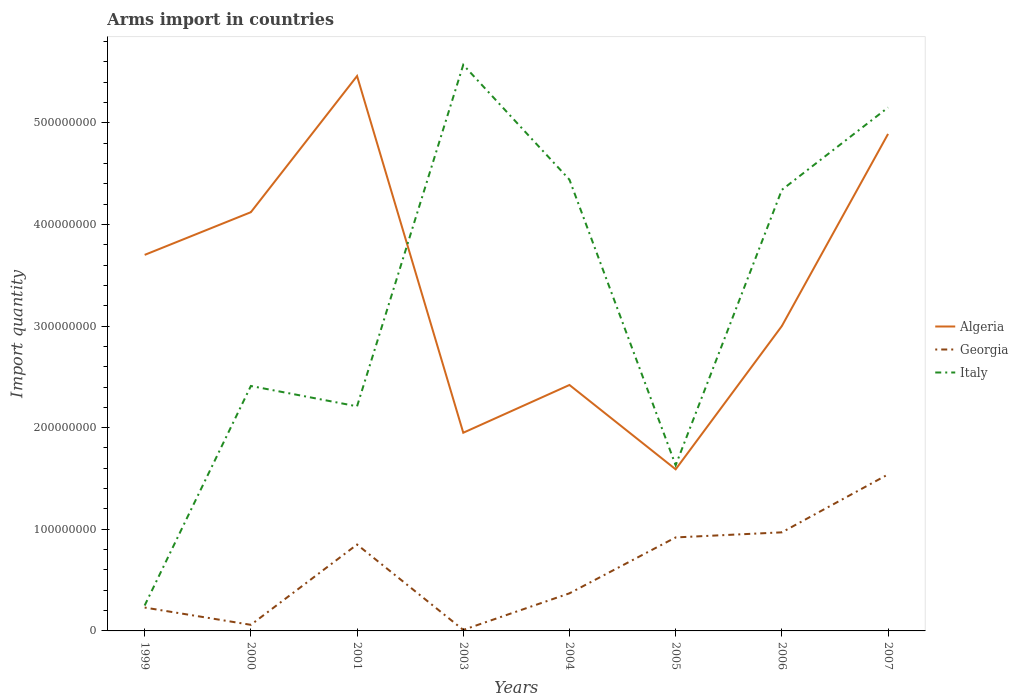Does the line corresponding to Algeria intersect with the line corresponding to Italy?
Offer a terse response. Yes. Is the number of lines equal to the number of legend labels?
Your answer should be very brief. Yes. Across all years, what is the maximum total arms import in Italy?
Give a very brief answer. 2.50e+07. In which year was the total arms import in Italy maximum?
Your answer should be compact. 1999. What is the total total arms import in Italy in the graph?
Make the answer very short. -4.90e+08. What is the difference between the highest and the second highest total arms import in Italy?
Ensure brevity in your answer.  5.32e+08. How many lines are there?
Give a very brief answer. 3. How many years are there in the graph?
Provide a short and direct response. 8. Does the graph contain any zero values?
Ensure brevity in your answer.  No. Does the graph contain grids?
Offer a very short reply. No. How are the legend labels stacked?
Offer a terse response. Vertical. What is the title of the graph?
Your answer should be very brief. Arms import in countries. What is the label or title of the X-axis?
Offer a very short reply. Years. What is the label or title of the Y-axis?
Give a very brief answer. Import quantity. What is the Import quantity in Algeria in 1999?
Your answer should be very brief. 3.70e+08. What is the Import quantity in Georgia in 1999?
Keep it short and to the point. 2.30e+07. What is the Import quantity in Italy in 1999?
Offer a terse response. 2.50e+07. What is the Import quantity of Algeria in 2000?
Your answer should be compact. 4.12e+08. What is the Import quantity of Italy in 2000?
Your answer should be very brief. 2.41e+08. What is the Import quantity in Algeria in 2001?
Offer a very short reply. 5.46e+08. What is the Import quantity of Georgia in 2001?
Your answer should be very brief. 8.50e+07. What is the Import quantity in Italy in 2001?
Your answer should be compact. 2.21e+08. What is the Import quantity in Algeria in 2003?
Your answer should be very brief. 1.95e+08. What is the Import quantity of Italy in 2003?
Provide a short and direct response. 5.57e+08. What is the Import quantity in Algeria in 2004?
Your answer should be very brief. 2.42e+08. What is the Import quantity of Georgia in 2004?
Give a very brief answer. 3.70e+07. What is the Import quantity in Italy in 2004?
Give a very brief answer. 4.44e+08. What is the Import quantity of Algeria in 2005?
Ensure brevity in your answer.  1.59e+08. What is the Import quantity of Georgia in 2005?
Provide a succinct answer. 9.20e+07. What is the Import quantity in Italy in 2005?
Provide a succinct answer. 1.63e+08. What is the Import quantity in Algeria in 2006?
Offer a terse response. 3.00e+08. What is the Import quantity in Georgia in 2006?
Offer a terse response. 9.70e+07. What is the Import quantity in Italy in 2006?
Offer a very short reply. 4.34e+08. What is the Import quantity in Algeria in 2007?
Provide a short and direct response. 4.89e+08. What is the Import quantity in Georgia in 2007?
Give a very brief answer. 1.54e+08. What is the Import quantity of Italy in 2007?
Your answer should be very brief. 5.15e+08. Across all years, what is the maximum Import quantity of Algeria?
Offer a terse response. 5.46e+08. Across all years, what is the maximum Import quantity in Georgia?
Offer a very short reply. 1.54e+08. Across all years, what is the maximum Import quantity of Italy?
Ensure brevity in your answer.  5.57e+08. Across all years, what is the minimum Import quantity of Algeria?
Your response must be concise. 1.59e+08. Across all years, what is the minimum Import quantity of Georgia?
Your answer should be very brief. 1.00e+06. Across all years, what is the minimum Import quantity in Italy?
Keep it short and to the point. 2.50e+07. What is the total Import quantity of Algeria in the graph?
Provide a succinct answer. 2.71e+09. What is the total Import quantity in Georgia in the graph?
Give a very brief answer. 4.95e+08. What is the total Import quantity in Italy in the graph?
Provide a short and direct response. 2.60e+09. What is the difference between the Import quantity in Algeria in 1999 and that in 2000?
Give a very brief answer. -4.20e+07. What is the difference between the Import quantity in Georgia in 1999 and that in 2000?
Offer a very short reply. 1.70e+07. What is the difference between the Import quantity in Italy in 1999 and that in 2000?
Your response must be concise. -2.16e+08. What is the difference between the Import quantity in Algeria in 1999 and that in 2001?
Make the answer very short. -1.76e+08. What is the difference between the Import quantity of Georgia in 1999 and that in 2001?
Offer a very short reply. -6.20e+07. What is the difference between the Import quantity of Italy in 1999 and that in 2001?
Your answer should be compact. -1.96e+08. What is the difference between the Import quantity in Algeria in 1999 and that in 2003?
Ensure brevity in your answer.  1.75e+08. What is the difference between the Import quantity in Georgia in 1999 and that in 2003?
Offer a terse response. 2.20e+07. What is the difference between the Import quantity in Italy in 1999 and that in 2003?
Offer a terse response. -5.32e+08. What is the difference between the Import quantity of Algeria in 1999 and that in 2004?
Make the answer very short. 1.28e+08. What is the difference between the Import quantity in Georgia in 1999 and that in 2004?
Give a very brief answer. -1.40e+07. What is the difference between the Import quantity of Italy in 1999 and that in 2004?
Ensure brevity in your answer.  -4.19e+08. What is the difference between the Import quantity of Algeria in 1999 and that in 2005?
Your response must be concise. 2.11e+08. What is the difference between the Import quantity of Georgia in 1999 and that in 2005?
Give a very brief answer. -6.90e+07. What is the difference between the Import quantity in Italy in 1999 and that in 2005?
Ensure brevity in your answer.  -1.38e+08. What is the difference between the Import quantity of Algeria in 1999 and that in 2006?
Your answer should be very brief. 7.00e+07. What is the difference between the Import quantity of Georgia in 1999 and that in 2006?
Your answer should be compact. -7.40e+07. What is the difference between the Import quantity in Italy in 1999 and that in 2006?
Make the answer very short. -4.09e+08. What is the difference between the Import quantity of Algeria in 1999 and that in 2007?
Make the answer very short. -1.19e+08. What is the difference between the Import quantity of Georgia in 1999 and that in 2007?
Make the answer very short. -1.31e+08. What is the difference between the Import quantity of Italy in 1999 and that in 2007?
Your answer should be compact. -4.90e+08. What is the difference between the Import quantity of Algeria in 2000 and that in 2001?
Keep it short and to the point. -1.34e+08. What is the difference between the Import quantity of Georgia in 2000 and that in 2001?
Provide a succinct answer. -7.90e+07. What is the difference between the Import quantity in Algeria in 2000 and that in 2003?
Ensure brevity in your answer.  2.17e+08. What is the difference between the Import quantity in Georgia in 2000 and that in 2003?
Provide a succinct answer. 5.00e+06. What is the difference between the Import quantity in Italy in 2000 and that in 2003?
Keep it short and to the point. -3.16e+08. What is the difference between the Import quantity of Algeria in 2000 and that in 2004?
Make the answer very short. 1.70e+08. What is the difference between the Import quantity in Georgia in 2000 and that in 2004?
Provide a short and direct response. -3.10e+07. What is the difference between the Import quantity in Italy in 2000 and that in 2004?
Your answer should be compact. -2.03e+08. What is the difference between the Import quantity in Algeria in 2000 and that in 2005?
Ensure brevity in your answer.  2.53e+08. What is the difference between the Import quantity of Georgia in 2000 and that in 2005?
Offer a very short reply. -8.60e+07. What is the difference between the Import quantity in Italy in 2000 and that in 2005?
Offer a terse response. 7.80e+07. What is the difference between the Import quantity in Algeria in 2000 and that in 2006?
Keep it short and to the point. 1.12e+08. What is the difference between the Import quantity of Georgia in 2000 and that in 2006?
Provide a short and direct response. -9.10e+07. What is the difference between the Import quantity of Italy in 2000 and that in 2006?
Keep it short and to the point. -1.93e+08. What is the difference between the Import quantity in Algeria in 2000 and that in 2007?
Your answer should be very brief. -7.70e+07. What is the difference between the Import quantity of Georgia in 2000 and that in 2007?
Offer a terse response. -1.48e+08. What is the difference between the Import quantity in Italy in 2000 and that in 2007?
Provide a succinct answer. -2.74e+08. What is the difference between the Import quantity in Algeria in 2001 and that in 2003?
Keep it short and to the point. 3.51e+08. What is the difference between the Import quantity of Georgia in 2001 and that in 2003?
Give a very brief answer. 8.40e+07. What is the difference between the Import quantity of Italy in 2001 and that in 2003?
Offer a terse response. -3.36e+08. What is the difference between the Import quantity in Algeria in 2001 and that in 2004?
Ensure brevity in your answer.  3.04e+08. What is the difference between the Import quantity in Georgia in 2001 and that in 2004?
Your answer should be compact. 4.80e+07. What is the difference between the Import quantity in Italy in 2001 and that in 2004?
Your response must be concise. -2.23e+08. What is the difference between the Import quantity in Algeria in 2001 and that in 2005?
Provide a short and direct response. 3.87e+08. What is the difference between the Import quantity of Georgia in 2001 and that in 2005?
Your answer should be compact. -7.00e+06. What is the difference between the Import quantity of Italy in 2001 and that in 2005?
Keep it short and to the point. 5.80e+07. What is the difference between the Import quantity of Algeria in 2001 and that in 2006?
Your answer should be compact. 2.46e+08. What is the difference between the Import quantity of Georgia in 2001 and that in 2006?
Provide a short and direct response. -1.20e+07. What is the difference between the Import quantity in Italy in 2001 and that in 2006?
Offer a very short reply. -2.13e+08. What is the difference between the Import quantity in Algeria in 2001 and that in 2007?
Keep it short and to the point. 5.70e+07. What is the difference between the Import quantity in Georgia in 2001 and that in 2007?
Ensure brevity in your answer.  -6.90e+07. What is the difference between the Import quantity of Italy in 2001 and that in 2007?
Provide a succinct answer. -2.94e+08. What is the difference between the Import quantity of Algeria in 2003 and that in 2004?
Give a very brief answer. -4.70e+07. What is the difference between the Import quantity of Georgia in 2003 and that in 2004?
Keep it short and to the point. -3.60e+07. What is the difference between the Import quantity in Italy in 2003 and that in 2004?
Provide a short and direct response. 1.13e+08. What is the difference between the Import quantity in Algeria in 2003 and that in 2005?
Provide a succinct answer. 3.60e+07. What is the difference between the Import quantity of Georgia in 2003 and that in 2005?
Your response must be concise. -9.10e+07. What is the difference between the Import quantity in Italy in 2003 and that in 2005?
Make the answer very short. 3.94e+08. What is the difference between the Import quantity of Algeria in 2003 and that in 2006?
Your answer should be very brief. -1.05e+08. What is the difference between the Import quantity in Georgia in 2003 and that in 2006?
Give a very brief answer. -9.60e+07. What is the difference between the Import quantity in Italy in 2003 and that in 2006?
Offer a very short reply. 1.23e+08. What is the difference between the Import quantity of Algeria in 2003 and that in 2007?
Your answer should be compact. -2.94e+08. What is the difference between the Import quantity of Georgia in 2003 and that in 2007?
Your answer should be compact. -1.53e+08. What is the difference between the Import quantity in Italy in 2003 and that in 2007?
Offer a terse response. 4.20e+07. What is the difference between the Import quantity of Algeria in 2004 and that in 2005?
Keep it short and to the point. 8.30e+07. What is the difference between the Import quantity in Georgia in 2004 and that in 2005?
Ensure brevity in your answer.  -5.50e+07. What is the difference between the Import quantity of Italy in 2004 and that in 2005?
Your answer should be very brief. 2.81e+08. What is the difference between the Import quantity of Algeria in 2004 and that in 2006?
Provide a short and direct response. -5.80e+07. What is the difference between the Import quantity of Georgia in 2004 and that in 2006?
Your response must be concise. -6.00e+07. What is the difference between the Import quantity of Algeria in 2004 and that in 2007?
Provide a succinct answer. -2.47e+08. What is the difference between the Import quantity of Georgia in 2004 and that in 2007?
Your response must be concise. -1.17e+08. What is the difference between the Import quantity in Italy in 2004 and that in 2007?
Provide a succinct answer. -7.10e+07. What is the difference between the Import quantity in Algeria in 2005 and that in 2006?
Make the answer very short. -1.41e+08. What is the difference between the Import quantity in Georgia in 2005 and that in 2006?
Provide a succinct answer. -5.00e+06. What is the difference between the Import quantity of Italy in 2005 and that in 2006?
Your response must be concise. -2.71e+08. What is the difference between the Import quantity in Algeria in 2005 and that in 2007?
Make the answer very short. -3.30e+08. What is the difference between the Import quantity in Georgia in 2005 and that in 2007?
Offer a terse response. -6.20e+07. What is the difference between the Import quantity of Italy in 2005 and that in 2007?
Offer a terse response. -3.52e+08. What is the difference between the Import quantity in Algeria in 2006 and that in 2007?
Ensure brevity in your answer.  -1.89e+08. What is the difference between the Import quantity of Georgia in 2006 and that in 2007?
Ensure brevity in your answer.  -5.70e+07. What is the difference between the Import quantity of Italy in 2006 and that in 2007?
Provide a succinct answer. -8.10e+07. What is the difference between the Import quantity of Algeria in 1999 and the Import quantity of Georgia in 2000?
Provide a short and direct response. 3.64e+08. What is the difference between the Import quantity in Algeria in 1999 and the Import quantity in Italy in 2000?
Keep it short and to the point. 1.29e+08. What is the difference between the Import quantity of Georgia in 1999 and the Import quantity of Italy in 2000?
Offer a very short reply. -2.18e+08. What is the difference between the Import quantity of Algeria in 1999 and the Import quantity of Georgia in 2001?
Ensure brevity in your answer.  2.85e+08. What is the difference between the Import quantity in Algeria in 1999 and the Import quantity in Italy in 2001?
Your answer should be compact. 1.49e+08. What is the difference between the Import quantity in Georgia in 1999 and the Import quantity in Italy in 2001?
Make the answer very short. -1.98e+08. What is the difference between the Import quantity in Algeria in 1999 and the Import quantity in Georgia in 2003?
Provide a short and direct response. 3.69e+08. What is the difference between the Import quantity of Algeria in 1999 and the Import quantity of Italy in 2003?
Offer a terse response. -1.87e+08. What is the difference between the Import quantity in Georgia in 1999 and the Import quantity in Italy in 2003?
Provide a short and direct response. -5.34e+08. What is the difference between the Import quantity in Algeria in 1999 and the Import quantity in Georgia in 2004?
Provide a short and direct response. 3.33e+08. What is the difference between the Import quantity of Algeria in 1999 and the Import quantity of Italy in 2004?
Your response must be concise. -7.40e+07. What is the difference between the Import quantity in Georgia in 1999 and the Import quantity in Italy in 2004?
Offer a terse response. -4.21e+08. What is the difference between the Import quantity in Algeria in 1999 and the Import quantity in Georgia in 2005?
Provide a succinct answer. 2.78e+08. What is the difference between the Import quantity in Algeria in 1999 and the Import quantity in Italy in 2005?
Your answer should be very brief. 2.07e+08. What is the difference between the Import quantity in Georgia in 1999 and the Import quantity in Italy in 2005?
Your response must be concise. -1.40e+08. What is the difference between the Import quantity of Algeria in 1999 and the Import quantity of Georgia in 2006?
Keep it short and to the point. 2.73e+08. What is the difference between the Import quantity of Algeria in 1999 and the Import quantity of Italy in 2006?
Provide a succinct answer. -6.40e+07. What is the difference between the Import quantity of Georgia in 1999 and the Import quantity of Italy in 2006?
Your response must be concise. -4.11e+08. What is the difference between the Import quantity of Algeria in 1999 and the Import quantity of Georgia in 2007?
Your answer should be compact. 2.16e+08. What is the difference between the Import quantity of Algeria in 1999 and the Import quantity of Italy in 2007?
Provide a short and direct response. -1.45e+08. What is the difference between the Import quantity in Georgia in 1999 and the Import quantity in Italy in 2007?
Offer a terse response. -4.92e+08. What is the difference between the Import quantity in Algeria in 2000 and the Import quantity in Georgia in 2001?
Your response must be concise. 3.27e+08. What is the difference between the Import quantity of Algeria in 2000 and the Import quantity of Italy in 2001?
Give a very brief answer. 1.91e+08. What is the difference between the Import quantity of Georgia in 2000 and the Import quantity of Italy in 2001?
Make the answer very short. -2.15e+08. What is the difference between the Import quantity in Algeria in 2000 and the Import quantity in Georgia in 2003?
Offer a very short reply. 4.11e+08. What is the difference between the Import quantity of Algeria in 2000 and the Import quantity of Italy in 2003?
Your answer should be compact. -1.45e+08. What is the difference between the Import quantity in Georgia in 2000 and the Import quantity in Italy in 2003?
Ensure brevity in your answer.  -5.51e+08. What is the difference between the Import quantity of Algeria in 2000 and the Import quantity of Georgia in 2004?
Offer a very short reply. 3.75e+08. What is the difference between the Import quantity of Algeria in 2000 and the Import quantity of Italy in 2004?
Provide a short and direct response. -3.20e+07. What is the difference between the Import quantity in Georgia in 2000 and the Import quantity in Italy in 2004?
Keep it short and to the point. -4.38e+08. What is the difference between the Import quantity in Algeria in 2000 and the Import quantity in Georgia in 2005?
Your answer should be very brief. 3.20e+08. What is the difference between the Import quantity of Algeria in 2000 and the Import quantity of Italy in 2005?
Provide a succinct answer. 2.49e+08. What is the difference between the Import quantity in Georgia in 2000 and the Import quantity in Italy in 2005?
Provide a short and direct response. -1.57e+08. What is the difference between the Import quantity in Algeria in 2000 and the Import quantity in Georgia in 2006?
Your response must be concise. 3.15e+08. What is the difference between the Import quantity in Algeria in 2000 and the Import quantity in Italy in 2006?
Your answer should be very brief. -2.20e+07. What is the difference between the Import quantity in Georgia in 2000 and the Import quantity in Italy in 2006?
Give a very brief answer. -4.28e+08. What is the difference between the Import quantity in Algeria in 2000 and the Import quantity in Georgia in 2007?
Your answer should be very brief. 2.58e+08. What is the difference between the Import quantity in Algeria in 2000 and the Import quantity in Italy in 2007?
Your answer should be very brief. -1.03e+08. What is the difference between the Import quantity of Georgia in 2000 and the Import quantity of Italy in 2007?
Provide a short and direct response. -5.09e+08. What is the difference between the Import quantity in Algeria in 2001 and the Import quantity in Georgia in 2003?
Provide a succinct answer. 5.45e+08. What is the difference between the Import quantity of Algeria in 2001 and the Import quantity of Italy in 2003?
Offer a very short reply. -1.10e+07. What is the difference between the Import quantity of Georgia in 2001 and the Import quantity of Italy in 2003?
Give a very brief answer. -4.72e+08. What is the difference between the Import quantity in Algeria in 2001 and the Import quantity in Georgia in 2004?
Your answer should be very brief. 5.09e+08. What is the difference between the Import quantity of Algeria in 2001 and the Import quantity of Italy in 2004?
Your answer should be compact. 1.02e+08. What is the difference between the Import quantity in Georgia in 2001 and the Import quantity in Italy in 2004?
Offer a terse response. -3.59e+08. What is the difference between the Import quantity in Algeria in 2001 and the Import quantity in Georgia in 2005?
Give a very brief answer. 4.54e+08. What is the difference between the Import quantity of Algeria in 2001 and the Import quantity of Italy in 2005?
Offer a very short reply. 3.83e+08. What is the difference between the Import quantity of Georgia in 2001 and the Import quantity of Italy in 2005?
Make the answer very short. -7.80e+07. What is the difference between the Import quantity of Algeria in 2001 and the Import quantity of Georgia in 2006?
Offer a terse response. 4.49e+08. What is the difference between the Import quantity of Algeria in 2001 and the Import quantity of Italy in 2006?
Provide a short and direct response. 1.12e+08. What is the difference between the Import quantity in Georgia in 2001 and the Import quantity in Italy in 2006?
Offer a very short reply. -3.49e+08. What is the difference between the Import quantity in Algeria in 2001 and the Import quantity in Georgia in 2007?
Provide a succinct answer. 3.92e+08. What is the difference between the Import quantity of Algeria in 2001 and the Import quantity of Italy in 2007?
Your answer should be very brief. 3.10e+07. What is the difference between the Import quantity of Georgia in 2001 and the Import quantity of Italy in 2007?
Provide a short and direct response. -4.30e+08. What is the difference between the Import quantity of Algeria in 2003 and the Import quantity of Georgia in 2004?
Provide a succinct answer. 1.58e+08. What is the difference between the Import quantity in Algeria in 2003 and the Import quantity in Italy in 2004?
Make the answer very short. -2.49e+08. What is the difference between the Import quantity in Georgia in 2003 and the Import quantity in Italy in 2004?
Offer a very short reply. -4.43e+08. What is the difference between the Import quantity of Algeria in 2003 and the Import quantity of Georgia in 2005?
Provide a short and direct response. 1.03e+08. What is the difference between the Import quantity in Algeria in 2003 and the Import quantity in Italy in 2005?
Offer a terse response. 3.20e+07. What is the difference between the Import quantity in Georgia in 2003 and the Import quantity in Italy in 2005?
Give a very brief answer. -1.62e+08. What is the difference between the Import quantity in Algeria in 2003 and the Import quantity in Georgia in 2006?
Provide a succinct answer. 9.80e+07. What is the difference between the Import quantity in Algeria in 2003 and the Import quantity in Italy in 2006?
Provide a short and direct response. -2.39e+08. What is the difference between the Import quantity of Georgia in 2003 and the Import quantity of Italy in 2006?
Provide a short and direct response. -4.33e+08. What is the difference between the Import quantity of Algeria in 2003 and the Import quantity of Georgia in 2007?
Keep it short and to the point. 4.10e+07. What is the difference between the Import quantity in Algeria in 2003 and the Import quantity in Italy in 2007?
Offer a very short reply. -3.20e+08. What is the difference between the Import quantity in Georgia in 2003 and the Import quantity in Italy in 2007?
Keep it short and to the point. -5.14e+08. What is the difference between the Import quantity in Algeria in 2004 and the Import quantity in Georgia in 2005?
Provide a succinct answer. 1.50e+08. What is the difference between the Import quantity of Algeria in 2004 and the Import quantity of Italy in 2005?
Offer a very short reply. 7.90e+07. What is the difference between the Import quantity in Georgia in 2004 and the Import quantity in Italy in 2005?
Offer a terse response. -1.26e+08. What is the difference between the Import quantity of Algeria in 2004 and the Import quantity of Georgia in 2006?
Keep it short and to the point. 1.45e+08. What is the difference between the Import quantity of Algeria in 2004 and the Import quantity of Italy in 2006?
Keep it short and to the point. -1.92e+08. What is the difference between the Import quantity of Georgia in 2004 and the Import quantity of Italy in 2006?
Keep it short and to the point. -3.97e+08. What is the difference between the Import quantity of Algeria in 2004 and the Import quantity of Georgia in 2007?
Ensure brevity in your answer.  8.80e+07. What is the difference between the Import quantity in Algeria in 2004 and the Import quantity in Italy in 2007?
Offer a very short reply. -2.73e+08. What is the difference between the Import quantity in Georgia in 2004 and the Import quantity in Italy in 2007?
Give a very brief answer. -4.78e+08. What is the difference between the Import quantity of Algeria in 2005 and the Import quantity of Georgia in 2006?
Provide a short and direct response. 6.20e+07. What is the difference between the Import quantity in Algeria in 2005 and the Import quantity in Italy in 2006?
Offer a very short reply. -2.75e+08. What is the difference between the Import quantity in Georgia in 2005 and the Import quantity in Italy in 2006?
Offer a very short reply. -3.42e+08. What is the difference between the Import quantity of Algeria in 2005 and the Import quantity of Italy in 2007?
Offer a very short reply. -3.56e+08. What is the difference between the Import quantity of Georgia in 2005 and the Import quantity of Italy in 2007?
Give a very brief answer. -4.23e+08. What is the difference between the Import quantity of Algeria in 2006 and the Import quantity of Georgia in 2007?
Your response must be concise. 1.46e+08. What is the difference between the Import quantity in Algeria in 2006 and the Import quantity in Italy in 2007?
Offer a very short reply. -2.15e+08. What is the difference between the Import quantity in Georgia in 2006 and the Import quantity in Italy in 2007?
Your answer should be very brief. -4.18e+08. What is the average Import quantity in Algeria per year?
Provide a succinct answer. 3.39e+08. What is the average Import quantity of Georgia per year?
Provide a short and direct response. 6.19e+07. What is the average Import quantity in Italy per year?
Provide a short and direct response. 3.25e+08. In the year 1999, what is the difference between the Import quantity in Algeria and Import quantity in Georgia?
Ensure brevity in your answer.  3.47e+08. In the year 1999, what is the difference between the Import quantity of Algeria and Import quantity of Italy?
Offer a terse response. 3.45e+08. In the year 1999, what is the difference between the Import quantity of Georgia and Import quantity of Italy?
Your response must be concise. -2.00e+06. In the year 2000, what is the difference between the Import quantity in Algeria and Import quantity in Georgia?
Your response must be concise. 4.06e+08. In the year 2000, what is the difference between the Import quantity of Algeria and Import quantity of Italy?
Your answer should be compact. 1.71e+08. In the year 2000, what is the difference between the Import quantity in Georgia and Import quantity in Italy?
Offer a very short reply. -2.35e+08. In the year 2001, what is the difference between the Import quantity of Algeria and Import quantity of Georgia?
Ensure brevity in your answer.  4.61e+08. In the year 2001, what is the difference between the Import quantity of Algeria and Import quantity of Italy?
Ensure brevity in your answer.  3.25e+08. In the year 2001, what is the difference between the Import quantity of Georgia and Import quantity of Italy?
Provide a short and direct response. -1.36e+08. In the year 2003, what is the difference between the Import quantity in Algeria and Import quantity in Georgia?
Provide a succinct answer. 1.94e+08. In the year 2003, what is the difference between the Import quantity in Algeria and Import quantity in Italy?
Make the answer very short. -3.62e+08. In the year 2003, what is the difference between the Import quantity of Georgia and Import quantity of Italy?
Your response must be concise. -5.56e+08. In the year 2004, what is the difference between the Import quantity of Algeria and Import quantity of Georgia?
Make the answer very short. 2.05e+08. In the year 2004, what is the difference between the Import quantity of Algeria and Import quantity of Italy?
Your response must be concise. -2.02e+08. In the year 2004, what is the difference between the Import quantity in Georgia and Import quantity in Italy?
Offer a very short reply. -4.07e+08. In the year 2005, what is the difference between the Import quantity of Algeria and Import quantity of Georgia?
Make the answer very short. 6.70e+07. In the year 2005, what is the difference between the Import quantity of Algeria and Import quantity of Italy?
Your response must be concise. -4.00e+06. In the year 2005, what is the difference between the Import quantity in Georgia and Import quantity in Italy?
Provide a succinct answer. -7.10e+07. In the year 2006, what is the difference between the Import quantity in Algeria and Import quantity in Georgia?
Your response must be concise. 2.03e+08. In the year 2006, what is the difference between the Import quantity of Algeria and Import quantity of Italy?
Offer a terse response. -1.34e+08. In the year 2006, what is the difference between the Import quantity of Georgia and Import quantity of Italy?
Offer a terse response. -3.37e+08. In the year 2007, what is the difference between the Import quantity of Algeria and Import quantity of Georgia?
Offer a terse response. 3.35e+08. In the year 2007, what is the difference between the Import quantity in Algeria and Import quantity in Italy?
Ensure brevity in your answer.  -2.60e+07. In the year 2007, what is the difference between the Import quantity in Georgia and Import quantity in Italy?
Keep it short and to the point. -3.61e+08. What is the ratio of the Import quantity in Algeria in 1999 to that in 2000?
Offer a very short reply. 0.9. What is the ratio of the Import quantity of Georgia in 1999 to that in 2000?
Your answer should be compact. 3.83. What is the ratio of the Import quantity of Italy in 1999 to that in 2000?
Your response must be concise. 0.1. What is the ratio of the Import quantity of Algeria in 1999 to that in 2001?
Your answer should be very brief. 0.68. What is the ratio of the Import quantity of Georgia in 1999 to that in 2001?
Offer a very short reply. 0.27. What is the ratio of the Import quantity of Italy in 1999 to that in 2001?
Your response must be concise. 0.11. What is the ratio of the Import quantity in Algeria in 1999 to that in 2003?
Your answer should be compact. 1.9. What is the ratio of the Import quantity in Italy in 1999 to that in 2003?
Ensure brevity in your answer.  0.04. What is the ratio of the Import quantity in Algeria in 1999 to that in 2004?
Make the answer very short. 1.53. What is the ratio of the Import quantity in Georgia in 1999 to that in 2004?
Provide a succinct answer. 0.62. What is the ratio of the Import quantity of Italy in 1999 to that in 2004?
Offer a terse response. 0.06. What is the ratio of the Import quantity in Algeria in 1999 to that in 2005?
Provide a short and direct response. 2.33. What is the ratio of the Import quantity in Italy in 1999 to that in 2005?
Keep it short and to the point. 0.15. What is the ratio of the Import quantity of Algeria in 1999 to that in 2006?
Provide a short and direct response. 1.23. What is the ratio of the Import quantity of Georgia in 1999 to that in 2006?
Offer a very short reply. 0.24. What is the ratio of the Import quantity of Italy in 1999 to that in 2006?
Ensure brevity in your answer.  0.06. What is the ratio of the Import quantity in Algeria in 1999 to that in 2007?
Your answer should be very brief. 0.76. What is the ratio of the Import quantity in Georgia in 1999 to that in 2007?
Offer a very short reply. 0.15. What is the ratio of the Import quantity of Italy in 1999 to that in 2007?
Make the answer very short. 0.05. What is the ratio of the Import quantity of Algeria in 2000 to that in 2001?
Keep it short and to the point. 0.75. What is the ratio of the Import quantity in Georgia in 2000 to that in 2001?
Provide a succinct answer. 0.07. What is the ratio of the Import quantity of Italy in 2000 to that in 2001?
Your answer should be very brief. 1.09. What is the ratio of the Import quantity of Algeria in 2000 to that in 2003?
Offer a terse response. 2.11. What is the ratio of the Import quantity in Georgia in 2000 to that in 2003?
Provide a short and direct response. 6. What is the ratio of the Import quantity of Italy in 2000 to that in 2003?
Your response must be concise. 0.43. What is the ratio of the Import quantity of Algeria in 2000 to that in 2004?
Make the answer very short. 1.7. What is the ratio of the Import quantity of Georgia in 2000 to that in 2004?
Offer a very short reply. 0.16. What is the ratio of the Import quantity of Italy in 2000 to that in 2004?
Your response must be concise. 0.54. What is the ratio of the Import quantity in Algeria in 2000 to that in 2005?
Provide a succinct answer. 2.59. What is the ratio of the Import quantity of Georgia in 2000 to that in 2005?
Your answer should be compact. 0.07. What is the ratio of the Import quantity in Italy in 2000 to that in 2005?
Give a very brief answer. 1.48. What is the ratio of the Import quantity in Algeria in 2000 to that in 2006?
Your answer should be very brief. 1.37. What is the ratio of the Import quantity of Georgia in 2000 to that in 2006?
Your answer should be very brief. 0.06. What is the ratio of the Import quantity in Italy in 2000 to that in 2006?
Your response must be concise. 0.56. What is the ratio of the Import quantity of Algeria in 2000 to that in 2007?
Offer a very short reply. 0.84. What is the ratio of the Import quantity in Georgia in 2000 to that in 2007?
Provide a short and direct response. 0.04. What is the ratio of the Import quantity in Italy in 2000 to that in 2007?
Provide a short and direct response. 0.47. What is the ratio of the Import quantity in Georgia in 2001 to that in 2003?
Keep it short and to the point. 85. What is the ratio of the Import quantity in Italy in 2001 to that in 2003?
Your answer should be very brief. 0.4. What is the ratio of the Import quantity of Algeria in 2001 to that in 2004?
Keep it short and to the point. 2.26. What is the ratio of the Import quantity of Georgia in 2001 to that in 2004?
Give a very brief answer. 2.3. What is the ratio of the Import quantity in Italy in 2001 to that in 2004?
Provide a succinct answer. 0.5. What is the ratio of the Import quantity in Algeria in 2001 to that in 2005?
Provide a short and direct response. 3.43. What is the ratio of the Import quantity in Georgia in 2001 to that in 2005?
Ensure brevity in your answer.  0.92. What is the ratio of the Import quantity of Italy in 2001 to that in 2005?
Your answer should be compact. 1.36. What is the ratio of the Import quantity of Algeria in 2001 to that in 2006?
Provide a short and direct response. 1.82. What is the ratio of the Import quantity of Georgia in 2001 to that in 2006?
Keep it short and to the point. 0.88. What is the ratio of the Import quantity of Italy in 2001 to that in 2006?
Your answer should be compact. 0.51. What is the ratio of the Import quantity in Algeria in 2001 to that in 2007?
Your answer should be compact. 1.12. What is the ratio of the Import quantity of Georgia in 2001 to that in 2007?
Your answer should be very brief. 0.55. What is the ratio of the Import quantity of Italy in 2001 to that in 2007?
Provide a short and direct response. 0.43. What is the ratio of the Import quantity in Algeria in 2003 to that in 2004?
Ensure brevity in your answer.  0.81. What is the ratio of the Import quantity in Georgia in 2003 to that in 2004?
Make the answer very short. 0.03. What is the ratio of the Import quantity in Italy in 2003 to that in 2004?
Your response must be concise. 1.25. What is the ratio of the Import quantity of Algeria in 2003 to that in 2005?
Provide a succinct answer. 1.23. What is the ratio of the Import quantity of Georgia in 2003 to that in 2005?
Ensure brevity in your answer.  0.01. What is the ratio of the Import quantity of Italy in 2003 to that in 2005?
Your answer should be very brief. 3.42. What is the ratio of the Import quantity in Algeria in 2003 to that in 2006?
Your answer should be compact. 0.65. What is the ratio of the Import quantity in Georgia in 2003 to that in 2006?
Ensure brevity in your answer.  0.01. What is the ratio of the Import quantity in Italy in 2003 to that in 2006?
Your answer should be compact. 1.28. What is the ratio of the Import quantity of Algeria in 2003 to that in 2007?
Ensure brevity in your answer.  0.4. What is the ratio of the Import quantity of Georgia in 2003 to that in 2007?
Offer a terse response. 0.01. What is the ratio of the Import quantity in Italy in 2003 to that in 2007?
Offer a terse response. 1.08. What is the ratio of the Import quantity of Algeria in 2004 to that in 2005?
Your answer should be compact. 1.52. What is the ratio of the Import quantity in Georgia in 2004 to that in 2005?
Ensure brevity in your answer.  0.4. What is the ratio of the Import quantity of Italy in 2004 to that in 2005?
Offer a very short reply. 2.72. What is the ratio of the Import quantity in Algeria in 2004 to that in 2006?
Make the answer very short. 0.81. What is the ratio of the Import quantity of Georgia in 2004 to that in 2006?
Offer a terse response. 0.38. What is the ratio of the Import quantity of Algeria in 2004 to that in 2007?
Offer a very short reply. 0.49. What is the ratio of the Import quantity of Georgia in 2004 to that in 2007?
Give a very brief answer. 0.24. What is the ratio of the Import quantity of Italy in 2004 to that in 2007?
Make the answer very short. 0.86. What is the ratio of the Import quantity of Algeria in 2005 to that in 2006?
Keep it short and to the point. 0.53. What is the ratio of the Import quantity of Georgia in 2005 to that in 2006?
Offer a very short reply. 0.95. What is the ratio of the Import quantity of Italy in 2005 to that in 2006?
Give a very brief answer. 0.38. What is the ratio of the Import quantity in Algeria in 2005 to that in 2007?
Provide a short and direct response. 0.33. What is the ratio of the Import quantity in Georgia in 2005 to that in 2007?
Offer a very short reply. 0.6. What is the ratio of the Import quantity in Italy in 2005 to that in 2007?
Keep it short and to the point. 0.32. What is the ratio of the Import quantity of Algeria in 2006 to that in 2007?
Ensure brevity in your answer.  0.61. What is the ratio of the Import quantity in Georgia in 2006 to that in 2007?
Make the answer very short. 0.63. What is the ratio of the Import quantity in Italy in 2006 to that in 2007?
Your answer should be compact. 0.84. What is the difference between the highest and the second highest Import quantity of Algeria?
Offer a very short reply. 5.70e+07. What is the difference between the highest and the second highest Import quantity in Georgia?
Your answer should be compact. 5.70e+07. What is the difference between the highest and the second highest Import quantity of Italy?
Keep it short and to the point. 4.20e+07. What is the difference between the highest and the lowest Import quantity of Algeria?
Offer a terse response. 3.87e+08. What is the difference between the highest and the lowest Import quantity in Georgia?
Your answer should be compact. 1.53e+08. What is the difference between the highest and the lowest Import quantity in Italy?
Provide a short and direct response. 5.32e+08. 